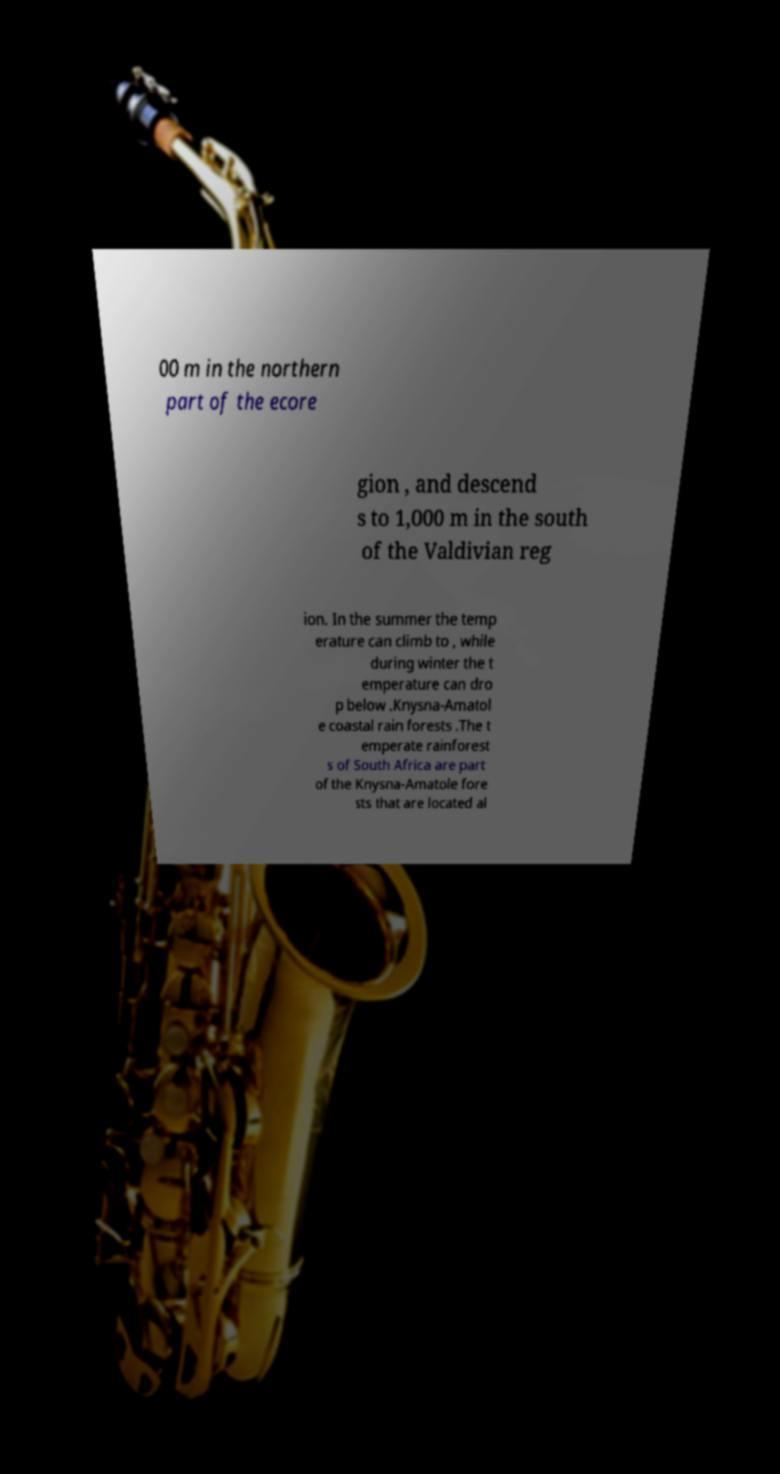There's text embedded in this image that I need extracted. Can you transcribe it verbatim? 00 m in the northern part of the ecore gion , and descend s to 1,000 m in the south of the Valdivian reg ion. In the summer the temp erature can climb to , while during winter the t emperature can dro p below .Knysna-Amatol e coastal rain forests .The t emperate rainforest s of South Africa are part of the Knysna-Amatole fore sts that are located al 